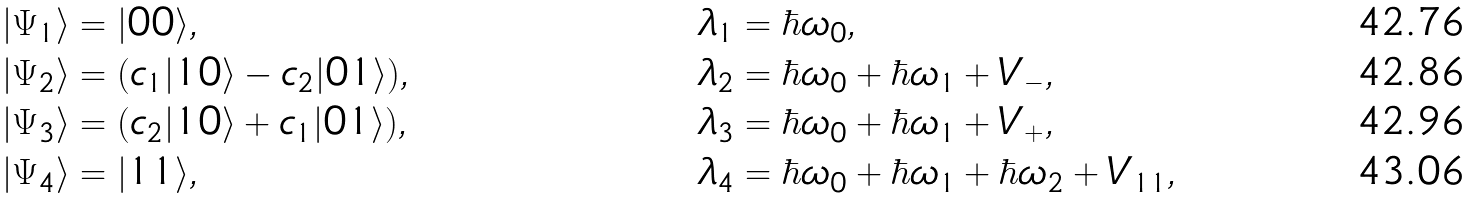<formula> <loc_0><loc_0><loc_500><loc_500>& | \Psi _ { 1 } \rangle = | 0 0 \rangle , & & \lambda _ { 1 } = \hbar { \omega } _ { 0 } , \\ & | \Psi _ { 2 } \rangle = ( c _ { 1 } | 1 0 \rangle - c _ { 2 } | 0 1 \rangle ) , & & \lambda _ { 2 } = \hbar { \omega } _ { 0 } + \hbar { \omega } _ { 1 } + V _ { - } , \\ & | \Psi _ { 3 } \rangle = ( c _ { 2 } | 1 0 \rangle + c _ { 1 } | 0 1 \rangle ) , & & \lambda _ { 3 } = \hbar { \omega } _ { 0 } + \hbar { \omega } _ { 1 } + V _ { + } , \\ & | \Psi _ { 4 } \rangle = | 1 1 \rangle , & & \lambda _ { 4 } = \hbar { \omega } _ { 0 } + \hbar { \omega } _ { 1 } + \hbar { \omega } _ { 2 } + V _ { 1 1 } ,</formula> 